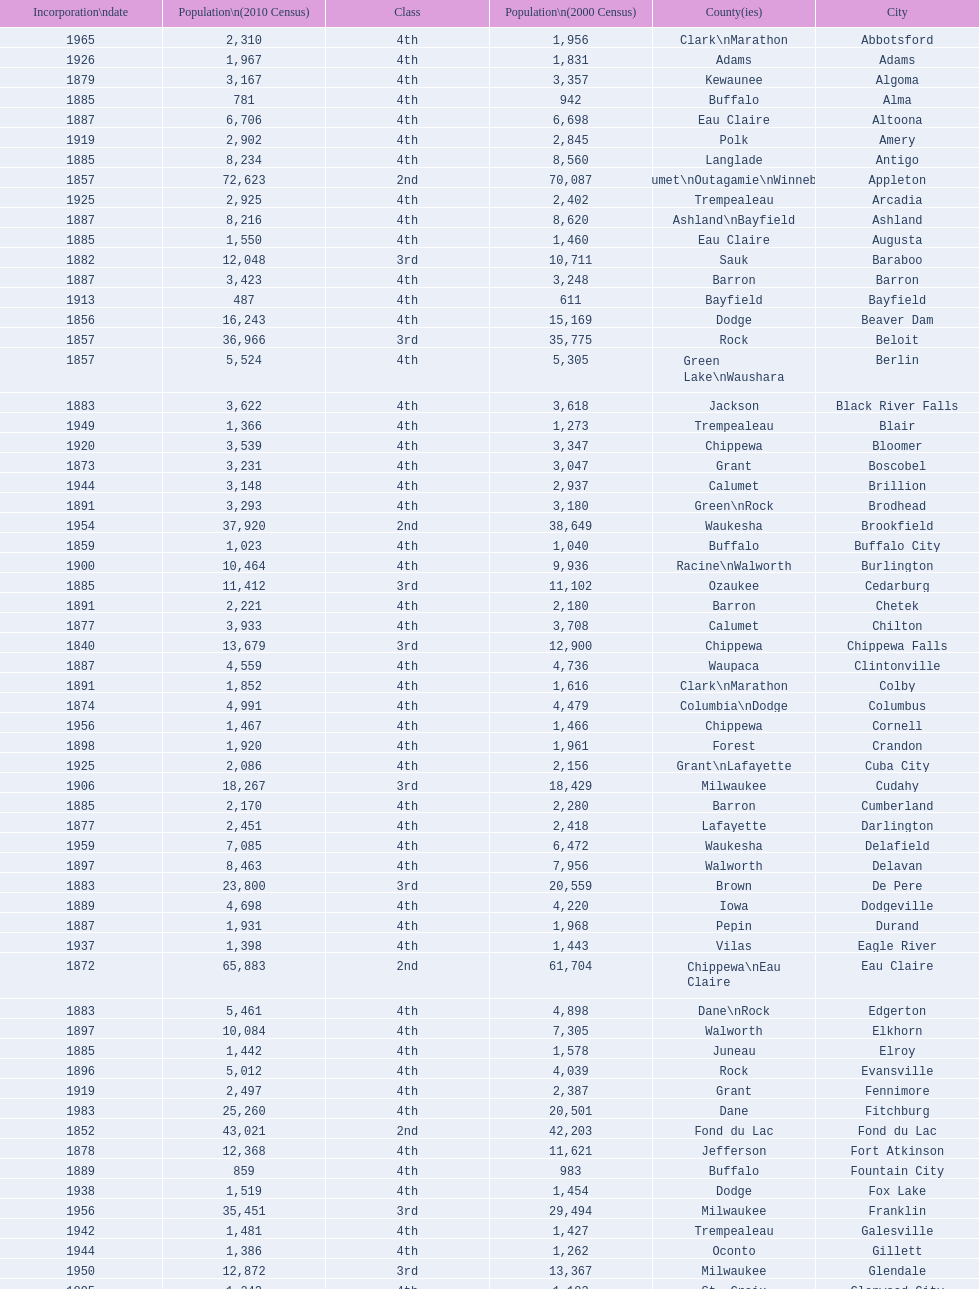County has altoona and augusta? Eau Claire. 